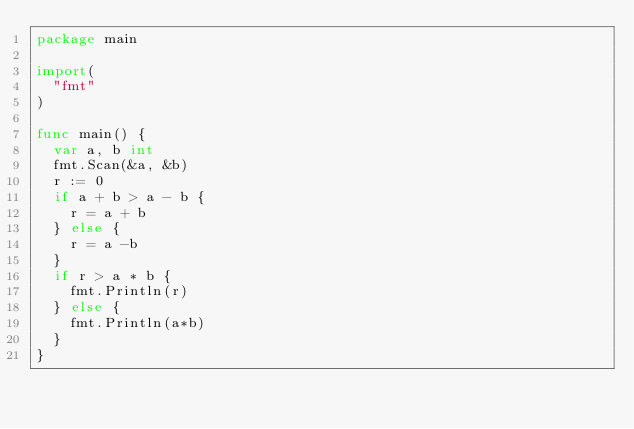Convert code to text. <code><loc_0><loc_0><loc_500><loc_500><_Go_>package main
 
import(
  "fmt"
)
 
func main() {
  var a, b int
  fmt.Scan(&a, &b)
  r := 0
  if a + b > a - b {
    r = a + b
  } else {
    r = a -b 
  }
  if r > a * b {
    fmt.Println(r)
  } else {
    fmt.Println(a*b)
  }
}</code> 